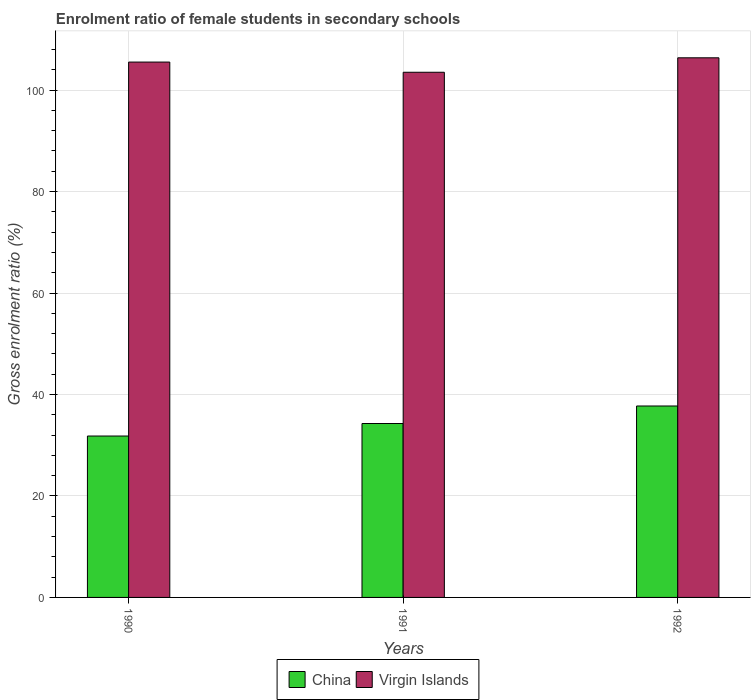Are the number of bars on each tick of the X-axis equal?
Provide a short and direct response. Yes. How many bars are there on the 2nd tick from the left?
Provide a short and direct response. 2. How many bars are there on the 3rd tick from the right?
Provide a succinct answer. 2. What is the label of the 1st group of bars from the left?
Offer a very short reply. 1990. What is the enrolment ratio of female students in secondary schools in Virgin Islands in 1990?
Your answer should be very brief. 105.52. Across all years, what is the maximum enrolment ratio of female students in secondary schools in China?
Make the answer very short. 37.73. Across all years, what is the minimum enrolment ratio of female students in secondary schools in Virgin Islands?
Offer a very short reply. 103.52. In which year was the enrolment ratio of female students in secondary schools in China minimum?
Your answer should be compact. 1990. What is the total enrolment ratio of female students in secondary schools in China in the graph?
Ensure brevity in your answer.  103.83. What is the difference between the enrolment ratio of female students in secondary schools in Virgin Islands in 1990 and that in 1992?
Your answer should be very brief. -0.84. What is the difference between the enrolment ratio of female students in secondary schools in Virgin Islands in 1991 and the enrolment ratio of female students in secondary schools in China in 1990?
Keep it short and to the point. 71.7. What is the average enrolment ratio of female students in secondary schools in China per year?
Your answer should be very brief. 34.61. In the year 1990, what is the difference between the enrolment ratio of female students in secondary schools in China and enrolment ratio of female students in secondary schools in Virgin Islands?
Make the answer very short. -73.71. What is the ratio of the enrolment ratio of female students in secondary schools in Virgin Islands in 1991 to that in 1992?
Ensure brevity in your answer.  0.97. Is the enrolment ratio of female students in secondary schools in Virgin Islands in 1991 less than that in 1992?
Provide a short and direct response. Yes. Is the difference between the enrolment ratio of female students in secondary schools in China in 1990 and 1992 greater than the difference between the enrolment ratio of female students in secondary schools in Virgin Islands in 1990 and 1992?
Offer a terse response. No. What is the difference between the highest and the second highest enrolment ratio of female students in secondary schools in China?
Your response must be concise. 3.45. What is the difference between the highest and the lowest enrolment ratio of female students in secondary schools in China?
Your answer should be very brief. 5.92. Is the sum of the enrolment ratio of female students in secondary schools in China in 1991 and 1992 greater than the maximum enrolment ratio of female students in secondary schools in Virgin Islands across all years?
Provide a succinct answer. No. What does the 2nd bar from the left in 1990 represents?
Make the answer very short. Virgin Islands. How many bars are there?
Offer a terse response. 6. Are the values on the major ticks of Y-axis written in scientific E-notation?
Keep it short and to the point. No. Does the graph contain grids?
Give a very brief answer. Yes. Where does the legend appear in the graph?
Keep it short and to the point. Bottom center. How many legend labels are there?
Provide a succinct answer. 2. What is the title of the graph?
Your answer should be very brief. Enrolment ratio of female students in secondary schools. Does "St. Vincent and the Grenadines" appear as one of the legend labels in the graph?
Make the answer very short. No. What is the label or title of the Y-axis?
Keep it short and to the point. Gross enrolment ratio (%). What is the Gross enrolment ratio (%) of China in 1990?
Make the answer very short. 31.81. What is the Gross enrolment ratio (%) of Virgin Islands in 1990?
Offer a very short reply. 105.52. What is the Gross enrolment ratio (%) of China in 1991?
Provide a short and direct response. 34.28. What is the Gross enrolment ratio (%) in Virgin Islands in 1991?
Offer a very short reply. 103.52. What is the Gross enrolment ratio (%) of China in 1992?
Provide a succinct answer. 37.73. What is the Gross enrolment ratio (%) in Virgin Islands in 1992?
Provide a short and direct response. 106.36. Across all years, what is the maximum Gross enrolment ratio (%) of China?
Offer a terse response. 37.73. Across all years, what is the maximum Gross enrolment ratio (%) in Virgin Islands?
Provide a short and direct response. 106.36. Across all years, what is the minimum Gross enrolment ratio (%) of China?
Offer a very short reply. 31.81. Across all years, what is the minimum Gross enrolment ratio (%) in Virgin Islands?
Offer a very short reply. 103.52. What is the total Gross enrolment ratio (%) in China in the graph?
Your answer should be very brief. 103.83. What is the total Gross enrolment ratio (%) in Virgin Islands in the graph?
Make the answer very short. 315.4. What is the difference between the Gross enrolment ratio (%) of China in 1990 and that in 1991?
Your answer should be compact. -2.47. What is the difference between the Gross enrolment ratio (%) in Virgin Islands in 1990 and that in 1991?
Give a very brief answer. 2.01. What is the difference between the Gross enrolment ratio (%) of China in 1990 and that in 1992?
Your answer should be compact. -5.92. What is the difference between the Gross enrolment ratio (%) in Virgin Islands in 1990 and that in 1992?
Provide a short and direct response. -0.84. What is the difference between the Gross enrolment ratio (%) in China in 1991 and that in 1992?
Make the answer very short. -3.45. What is the difference between the Gross enrolment ratio (%) of Virgin Islands in 1991 and that in 1992?
Offer a terse response. -2.85. What is the difference between the Gross enrolment ratio (%) in China in 1990 and the Gross enrolment ratio (%) in Virgin Islands in 1991?
Your answer should be very brief. -71.7. What is the difference between the Gross enrolment ratio (%) in China in 1990 and the Gross enrolment ratio (%) in Virgin Islands in 1992?
Your response must be concise. -74.55. What is the difference between the Gross enrolment ratio (%) in China in 1991 and the Gross enrolment ratio (%) in Virgin Islands in 1992?
Keep it short and to the point. -72.08. What is the average Gross enrolment ratio (%) of China per year?
Keep it short and to the point. 34.61. What is the average Gross enrolment ratio (%) in Virgin Islands per year?
Give a very brief answer. 105.13. In the year 1990, what is the difference between the Gross enrolment ratio (%) of China and Gross enrolment ratio (%) of Virgin Islands?
Offer a terse response. -73.71. In the year 1991, what is the difference between the Gross enrolment ratio (%) in China and Gross enrolment ratio (%) in Virgin Islands?
Your answer should be very brief. -69.23. In the year 1992, what is the difference between the Gross enrolment ratio (%) in China and Gross enrolment ratio (%) in Virgin Islands?
Provide a short and direct response. -68.63. What is the ratio of the Gross enrolment ratio (%) of China in 1990 to that in 1991?
Your answer should be compact. 0.93. What is the ratio of the Gross enrolment ratio (%) in Virgin Islands in 1990 to that in 1991?
Your answer should be very brief. 1.02. What is the ratio of the Gross enrolment ratio (%) of China in 1990 to that in 1992?
Keep it short and to the point. 0.84. What is the ratio of the Gross enrolment ratio (%) in China in 1991 to that in 1992?
Provide a short and direct response. 0.91. What is the ratio of the Gross enrolment ratio (%) of Virgin Islands in 1991 to that in 1992?
Give a very brief answer. 0.97. What is the difference between the highest and the second highest Gross enrolment ratio (%) in China?
Ensure brevity in your answer.  3.45. What is the difference between the highest and the second highest Gross enrolment ratio (%) in Virgin Islands?
Give a very brief answer. 0.84. What is the difference between the highest and the lowest Gross enrolment ratio (%) in China?
Provide a short and direct response. 5.92. What is the difference between the highest and the lowest Gross enrolment ratio (%) of Virgin Islands?
Your answer should be very brief. 2.85. 